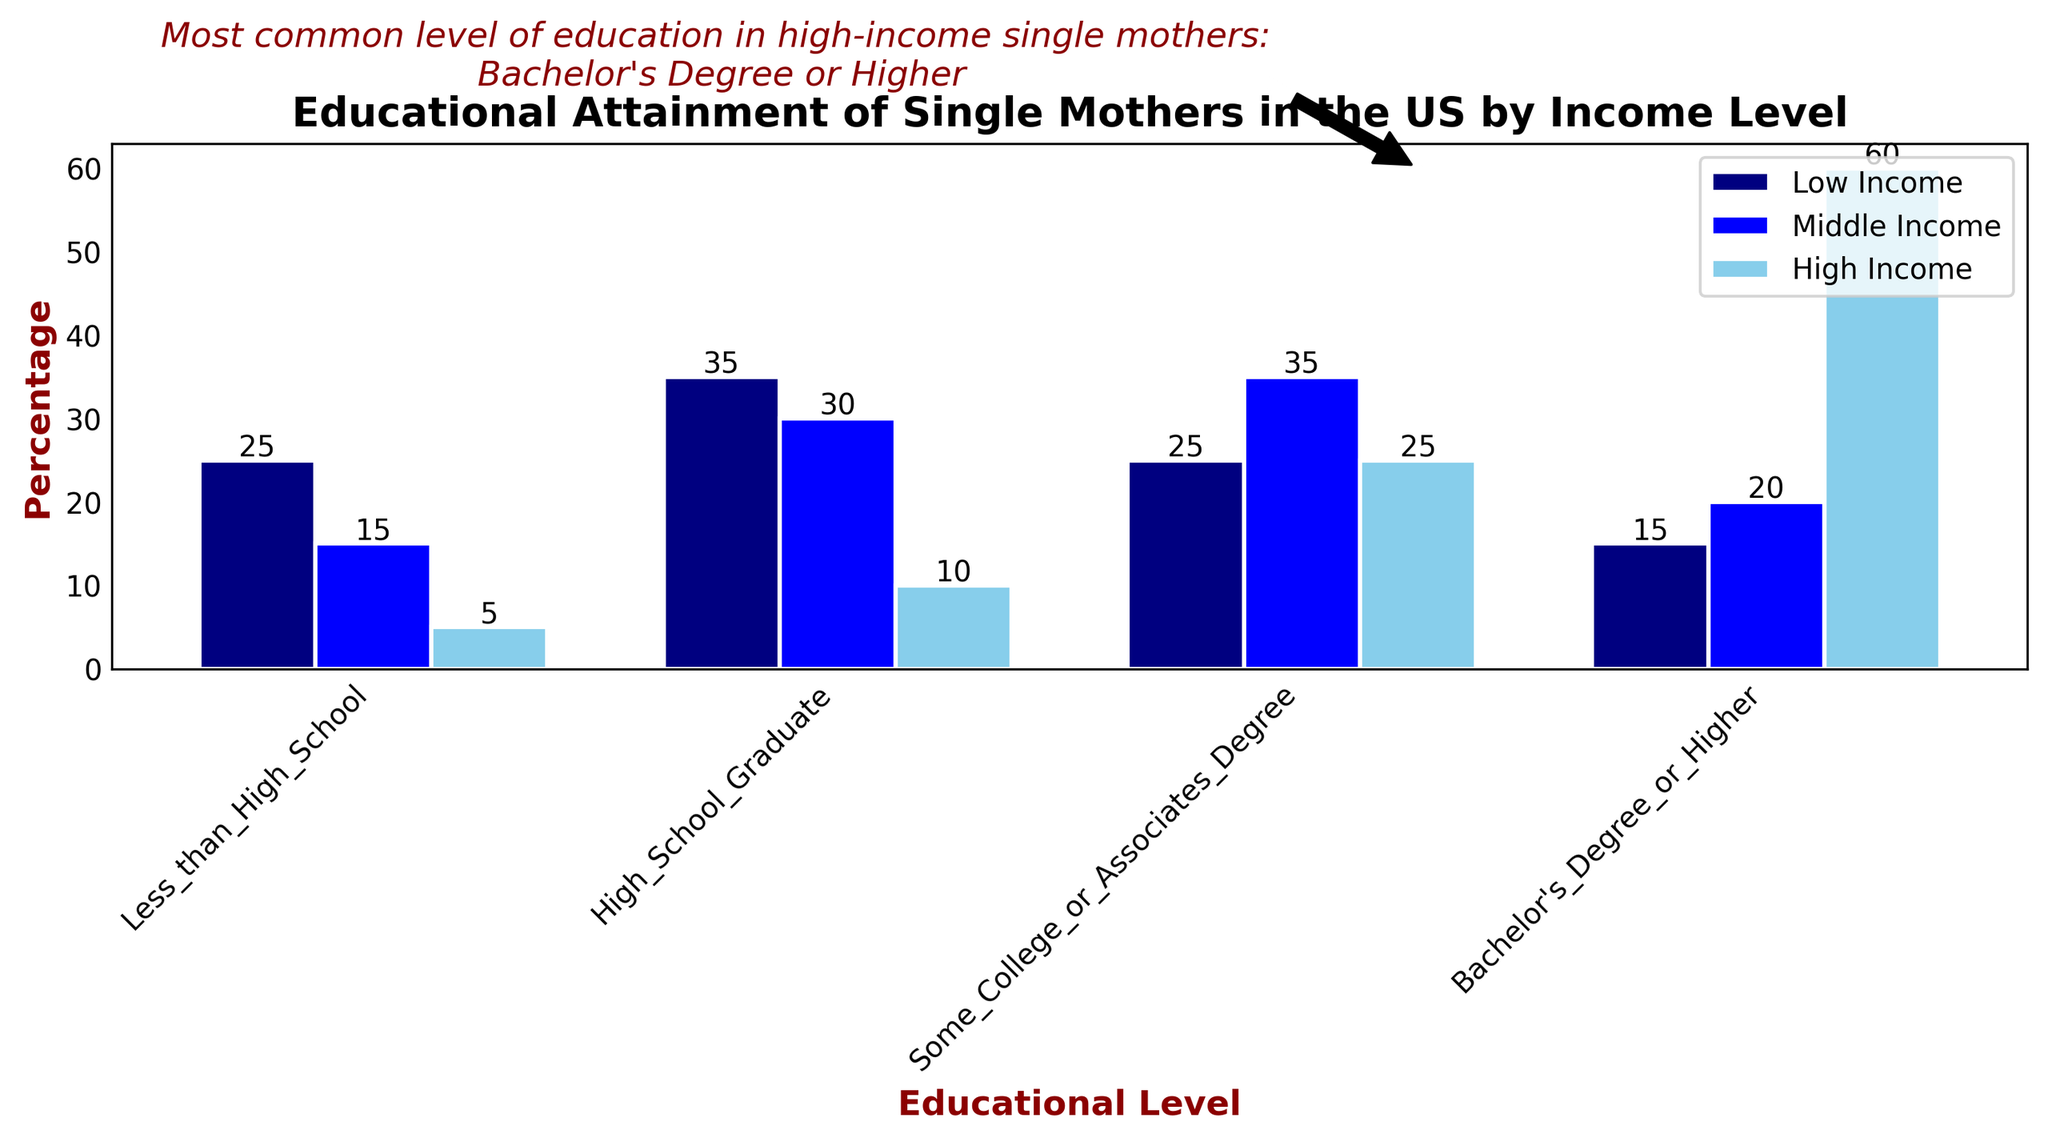What percentage of low-income single mothers have less than a high school education? Look at the bar labeled 'Less_than_High_School' for the 'Low Income' group; the height of the bar indicates 25%.
Answer: 25% Which group has the highest percentage of single mothers with a Bachelor's Degree or Higher? Compare the heights of the 'Bachelor's Degree_or_Higher' bars for all income groups. The 'High Income' group has the tallest bar at 60%.
Answer: High Income What is the total percentage of middle-income single mothers with some college or an associate's degree and those with a bachelor's degree or higher? Add the percentages for 'Some_College_or_Associates_Degree' and 'Bachelor's_Degree_or_Higher' in the 'Middle Income' group: 35% + 20% = 55%.
Answer: 55% Which educational level has the same percentage of single mothers in both the low income and middle income groups? Check each educational level where the heights of the bars for 'Low Income' and 'Middle Income' are the same. Both have 'Less_than_High_School' with no match, 'High_School_Graduate' with no match, 'Some_College_or_Associates_Degree' where they are not equal, and 'Bachelor's_Degree_or_Higher' where there's no match either. There is no matching percentage.
Answer: None What is the difference in percentage between high-income and low-income single mothers with only a high school education? Subtract the 'High_School_Graduate' percentage for 'Low Income' (35%) from 'High Income' (10%): 35% - 10% = 25%.
Answer: 25% How does the percentage of low-income single mothers with some college or an associate's degree compare to the percentage of middle-income single mothers with the same level of education? Compare the heights of the bars for 'Some_College_or_Associates_Degree' in the 'Low Income' and 'Middle Income' groups. Low Income is 25%, and Middle Income is 35%. Middle Income is higher.
Answer: Middle Income is higher What can you deduce about the educational level most common among high-income single mothers? Look at the highest bar within the 'High Income' group. 'Bachelor's Degree_or_Higher' has the highest bar at 60%, indicating it is the most common educational level.
Answer: Bachelor's Degree or Higher What proportion of high-income single mothers have less than a high school education compared to low-income single mothers with the same educational level? Compare 'Less_than_High_School' for both 'High Income' (5%) and 'Low Income' (25%). High Income has much fewer single mothers with this education level.
Answer: High Income has fewer How many percentage points more are high-income single mothers with a Bachelor's degree or higher compared to middle-income single mothers with the same education level? Subtract the 'Bachelor's_Degree_or_Higher' percentage for 'Middle Income' (20%) from 'High Income' (60%): 60% - 20% = 40%.
Answer: 40% How does the percentage for high school graduates among low-income single mothers compare to middle-income single mothers? Compare the 'High_School_Graduate' bars for 'Low Income' (35%) and 'Middle Income' (30%). The Low Income percentage is slightly higher than the Middle Income.
Answer: Low Income is higher 